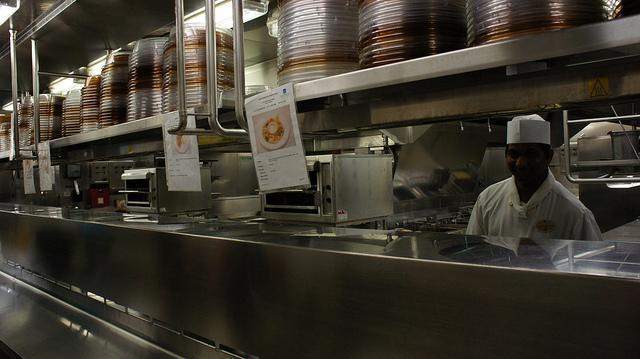How many microwaves can you see?
Give a very brief answer. 1. 